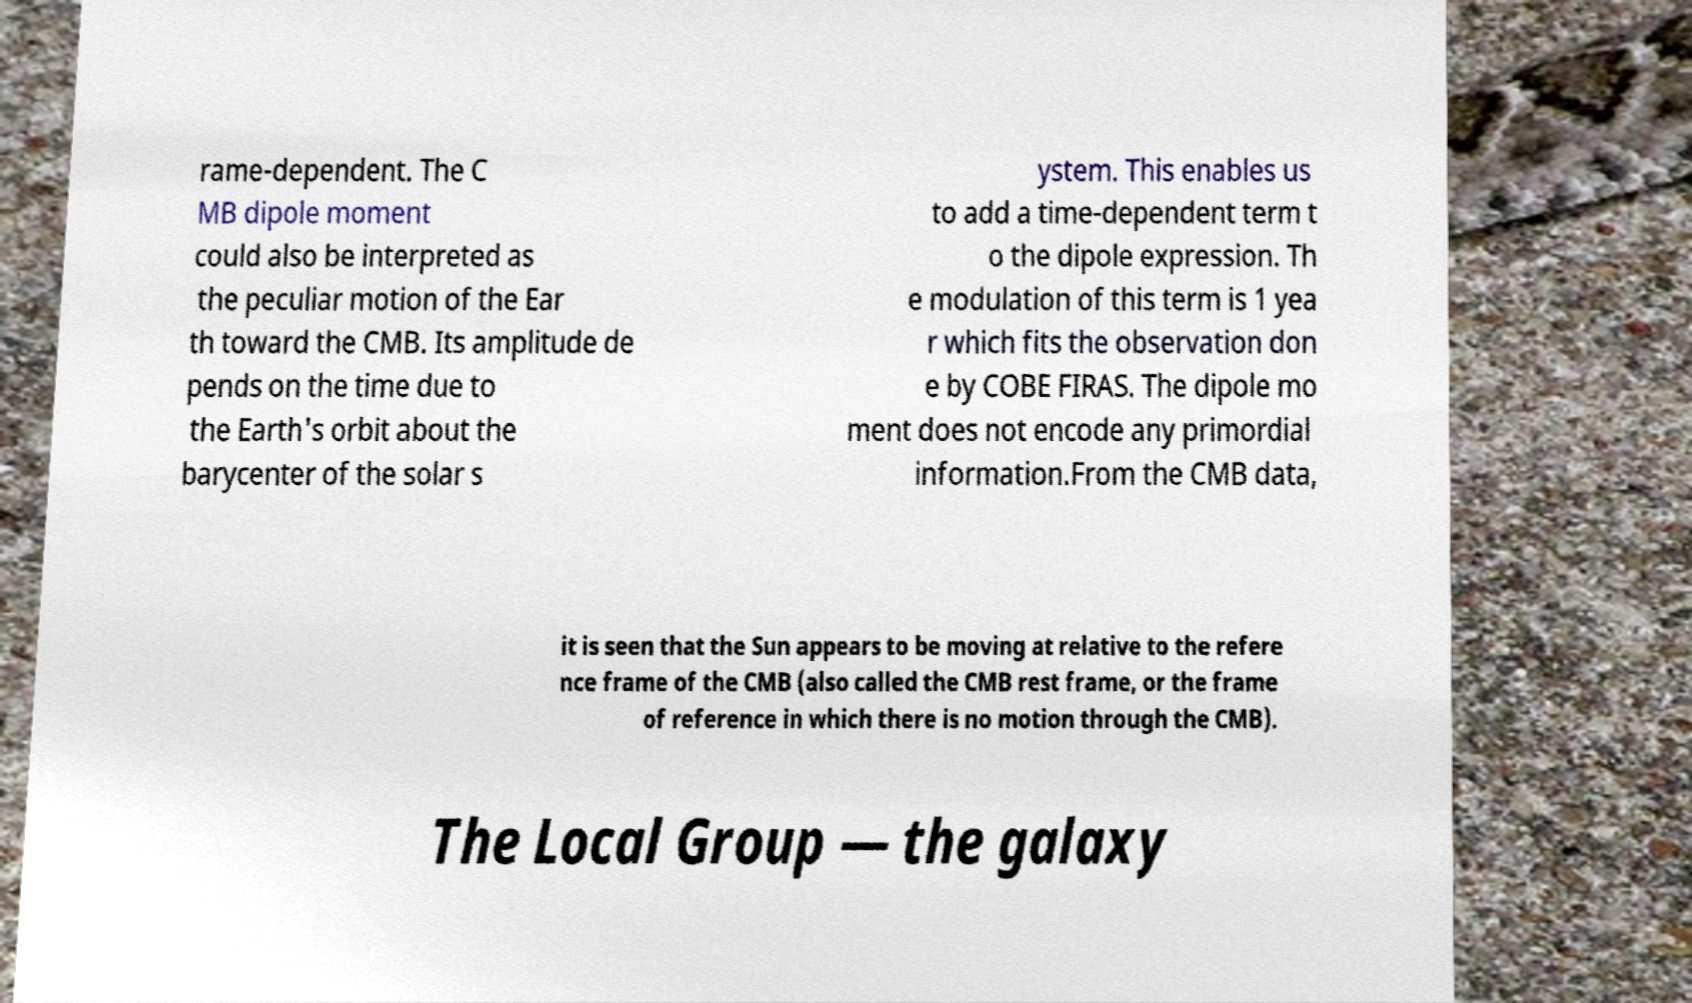For documentation purposes, I need the text within this image transcribed. Could you provide that? rame-dependent. The C MB dipole moment could also be interpreted as the peculiar motion of the Ear th toward the CMB. Its amplitude de pends on the time due to the Earth's orbit about the barycenter of the solar s ystem. This enables us to add a time-dependent term t o the dipole expression. Th e modulation of this term is 1 yea r which fits the observation don e by COBE FIRAS. The dipole mo ment does not encode any primordial information.From the CMB data, it is seen that the Sun appears to be moving at relative to the refere nce frame of the CMB (also called the CMB rest frame, or the frame of reference in which there is no motion through the CMB). The Local Group — the galaxy 